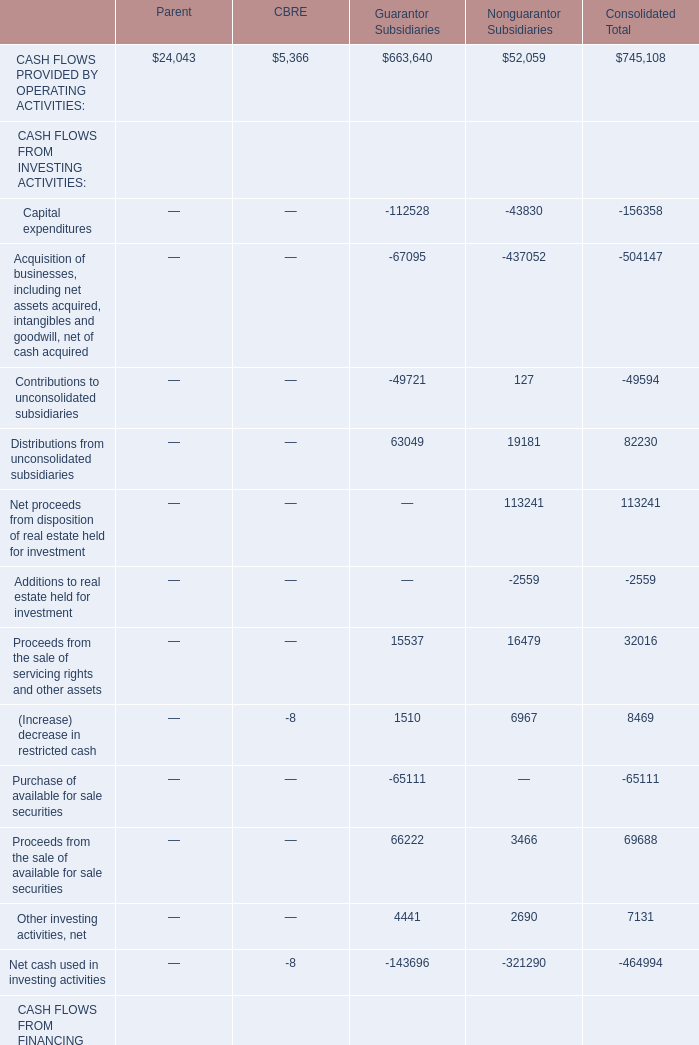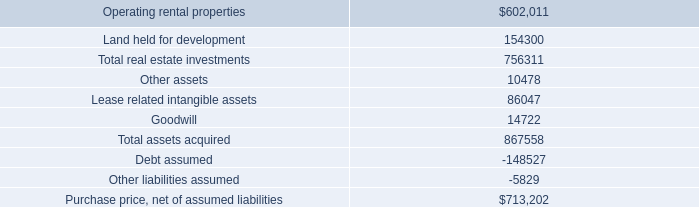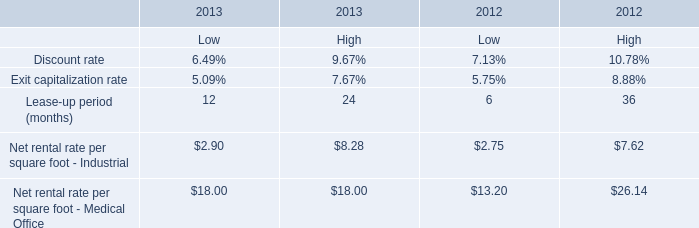What's the total value of all CASH FLOWS PROVIDED BY OPERATING ACTIVITIES that are smaller than 10000 in the year showed as table 1? (in dollars) 
Answer: 5366. 